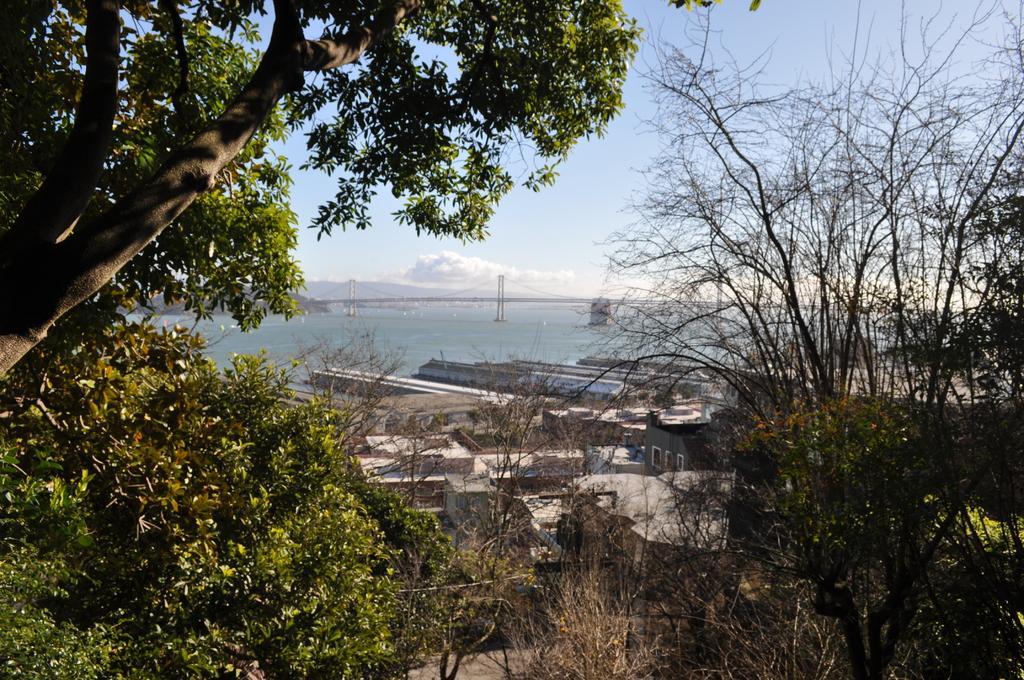Could you give a brief overview of what you see in this image? In this image in the front there are trees and in the center there are buildings. In the background is an ocean and the sky is cloudy. 